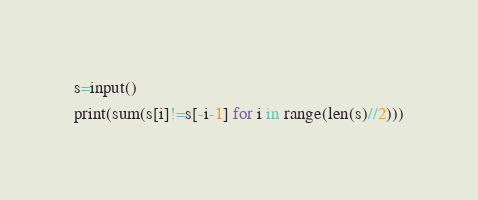<code> <loc_0><loc_0><loc_500><loc_500><_Python_>s=input()
print(sum(s[i]!=s[-i-1] for i in range(len(s)//2)))
</code> 